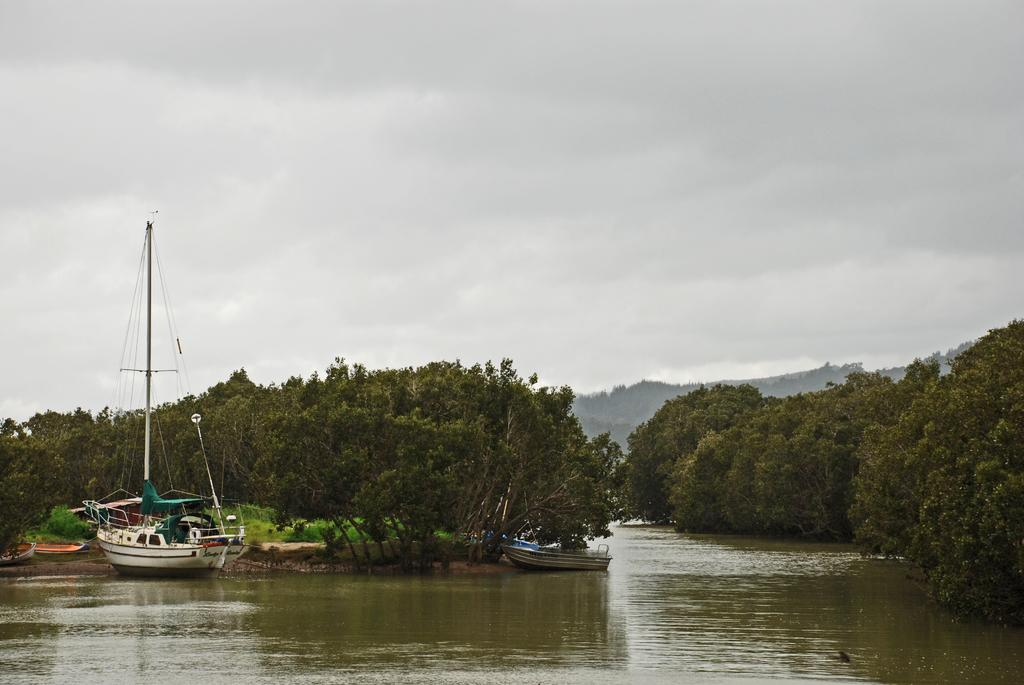What is the main feature of the image? The main feature of the image is water. What can be seen on the water? There are boats on the water. What type of vegetation is present in the image? There are trees in the image. What is visible in the background of the image? The sky is visible in the background of the image. What is the weather like in the image? The sky appears to be cloudy, suggesting a potentially overcast or rainy day. How many hands are visible holding the fan in the image? There is no fan or hands present in the image. In which direction is the north indicated in the image? There is no indication of direction, such as north, in the image. 